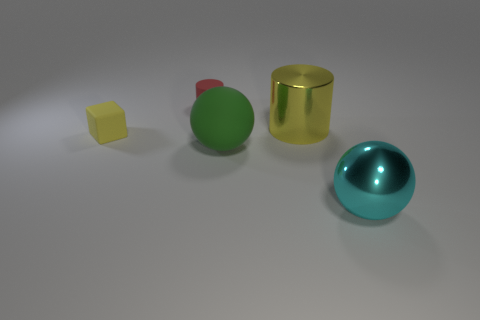Add 5 balls. How many objects exist? 10 Subtract all balls. How many objects are left? 3 Subtract all big cyan balls. Subtract all small purple rubber cylinders. How many objects are left? 4 Add 4 red cylinders. How many red cylinders are left? 5 Add 3 small red objects. How many small red objects exist? 4 Subtract 0 purple spheres. How many objects are left? 5 